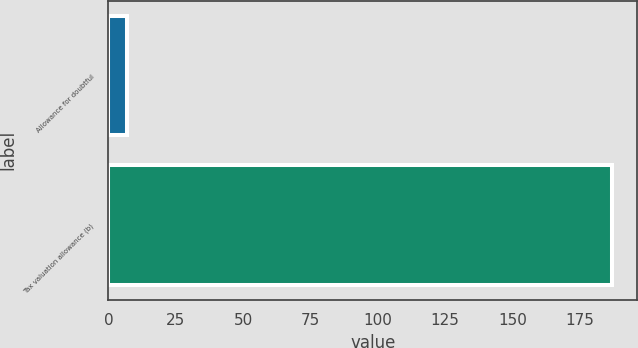Convert chart to OTSL. <chart><loc_0><loc_0><loc_500><loc_500><bar_chart><fcel>Allowance for doubtful<fcel>Tax valuation allowance (b)<nl><fcel>7<fcel>187<nl></chart> 